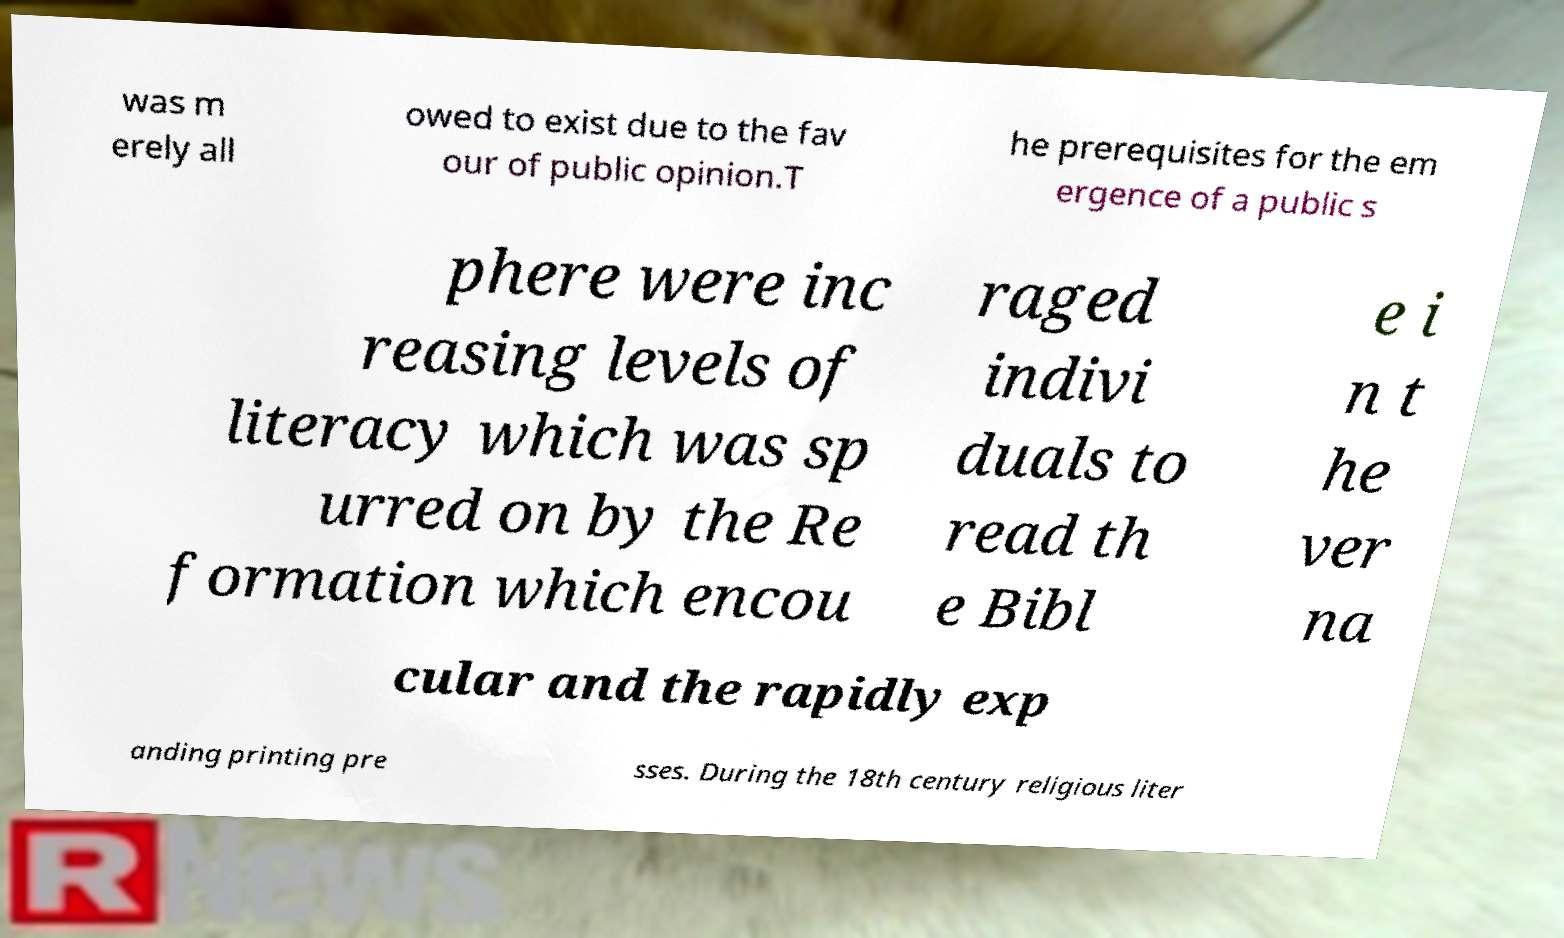Can you read and provide the text displayed in the image?This photo seems to have some interesting text. Can you extract and type it out for me? was m erely all owed to exist due to the fav our of public opinion.T he prerequisites for the em ergence of a public s phere were inc reasing levels of literacy which was sp urred on by the Re formation which encou raged indivi duals to read th e Bibl e i n t he ver na cular and the rapidly exp anding printing pre sses. During the 18th century religious liter 